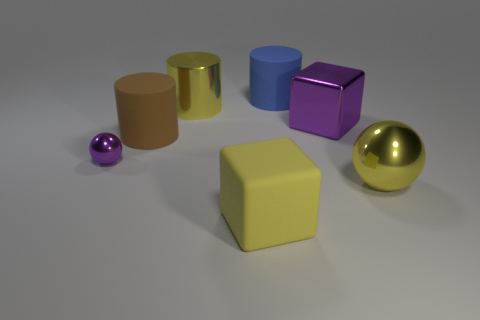What is the shape of the shiny thing that is the same color as the big metallic cylinder?
Provide a short and direct response. Sphere. How many things are large green spheres or yellow shiny things in front of the brown matte cylinder?
Offer a very short reply. 1. Are the large purple block and the big yellow sphere made of the same material?
Offer a terse response. Yes. What number of other objects are the same shape as the large yellow rubber thing?
Provide a short and direct response. 1. What size is the metal object that is right of the tiny purple metallic sphere and left of the yellow cube?
Your response must be concise. Large. How many metallic things are yellow spheres or tiny purple things?
Offer a very short reply. 2. Do the purple object left of the large brown rubber thing and the metallic object that is to the right of the purple cube have the same shape?
Keep it short and to the point. Yes. Is there a tiny purple cylinder made of the same material as the yellow cylinder?
Make the answer very short. No. What color is the tiny ball?
Your answer should be very brief. Purple. How big is the purple metal thing behind the large brown cylinder?
Provide a short and direct response. Large. 